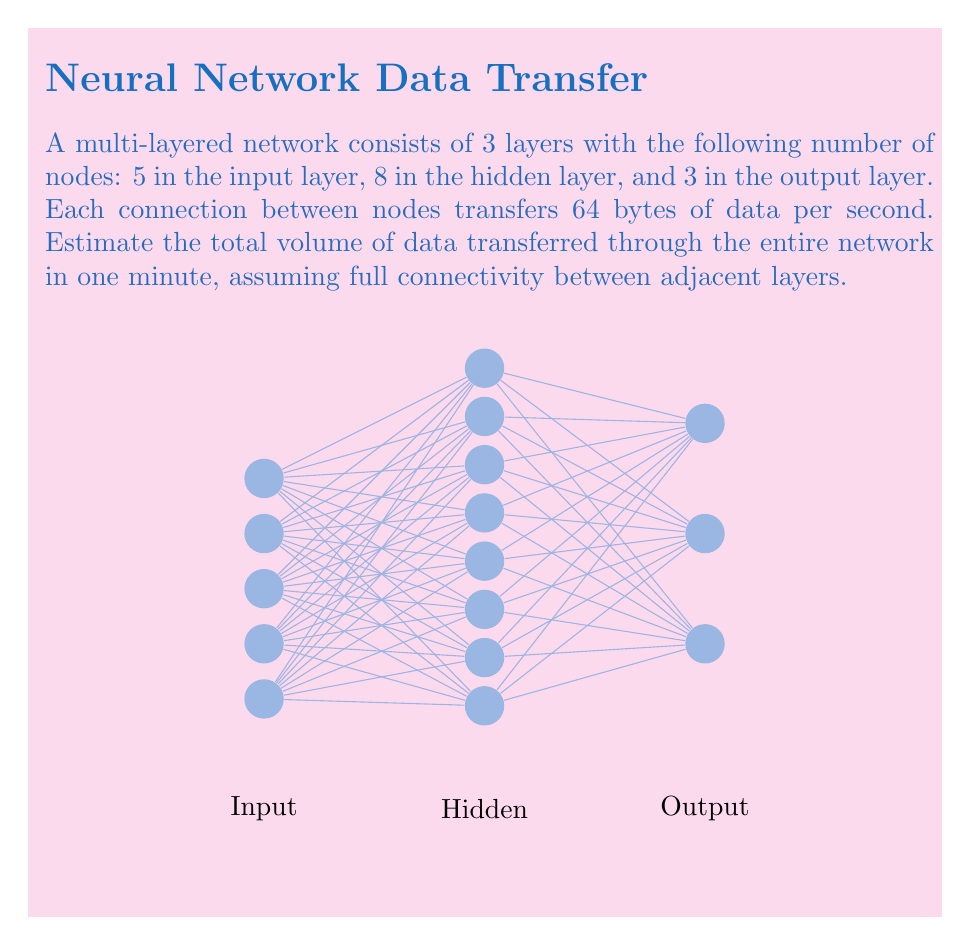Can you solve this math problem? Let's break this down step-by-step:

1) First, we need to calculate the number of connections between layers:
   - Between input and hidden layers: $5 \times 8 = 40$ connections
   - Between hidden and output layers: $8 \times 3 = 24$ connections

2) Total number of connections:
   $40 + 24 = 64$ connections

3) Each connection transfers 64 bytes per second. So, the total data transfer per second is:
   $64 \text{ connections} \times 64 \text{ bytes/second} = 4,096 \text{ bytes/second}$

4) To convert this to a minute, we multiply by 60:
   $4,096 \text{ bytes/second} \times 60 \text{ seconds} = 245,760 \text{ bytes/minute}$

5) Convert bytes to megabytes:
   $\frac{245,760 \text{ bytes}}{1,048,576 \text{ bytes/MB}} \approx 0.2344 \text{ MB/minute}$

Therefore, the estimated volume of data transferred through the entire network in one minute is approximately 0.2344 MB.
Answer: $0.2344 \text{ MB}$ 